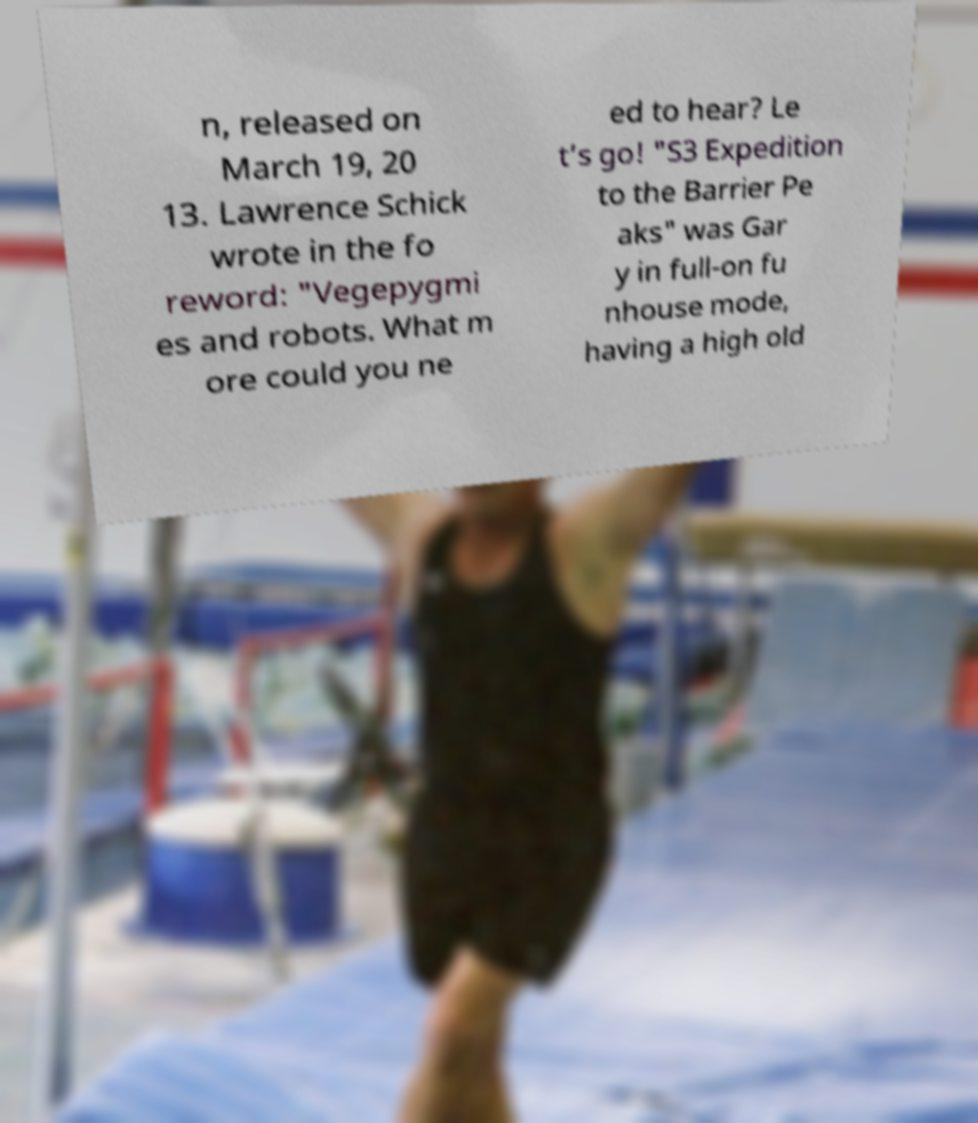Can you accurately transcribe the text from the provided image for me? n, released on March 19, 20 13. Lawrence Schick wrote in the fo reword: "Vegepygmi es and robots. What m ore could you ne ed to hear? Le t’s go! "S3 Expedition to the Barrier Pe aks" was Gar y in full-on fu nhouse mode, having a high old 